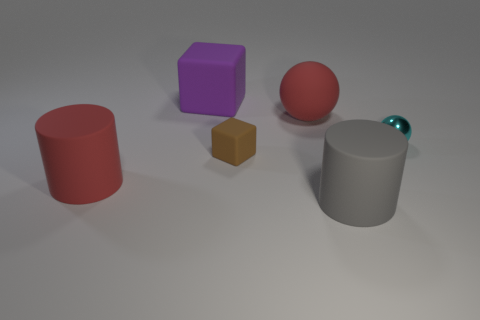Add 2 green cubes. How many objects exist? 8 Subtract all cubes. How many objects are left? 4 Subtract 0 yellow cylinders. How many objects are left? 6 Subtract all red matte cylinders. Subtract all small cubes. How many objects are left? 4 Add 4 large red rubber balls. How many large red rubber balls are left? 5 Add 2 big gray rubber cylinders. How many big gray rubber cylinders exist? 3 